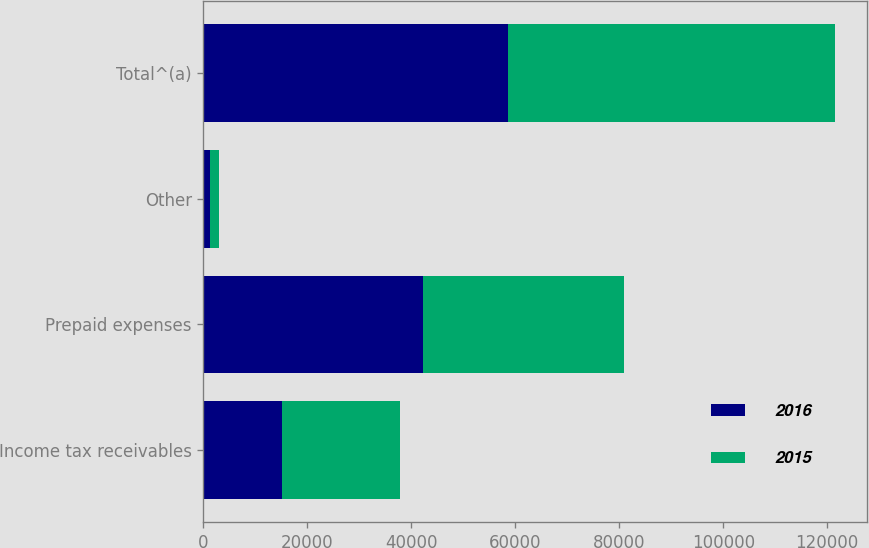Convert chart to OTSL. <chart><loc_0><loc_0><loc_500><loc_500><stacked_bar_chart><ecel><fcel>Income tax receivables<fcel>Prepaid expenses<fcel>Other<fcel>Total^(a)<nl><fcel>2016<fcel>15085<fcel>42240<fcel>1254<fcel>58579<nl><fcel>2015<fcel>22649<fcel>38609<fcel>1664<fcel>62922<nl></chart> 